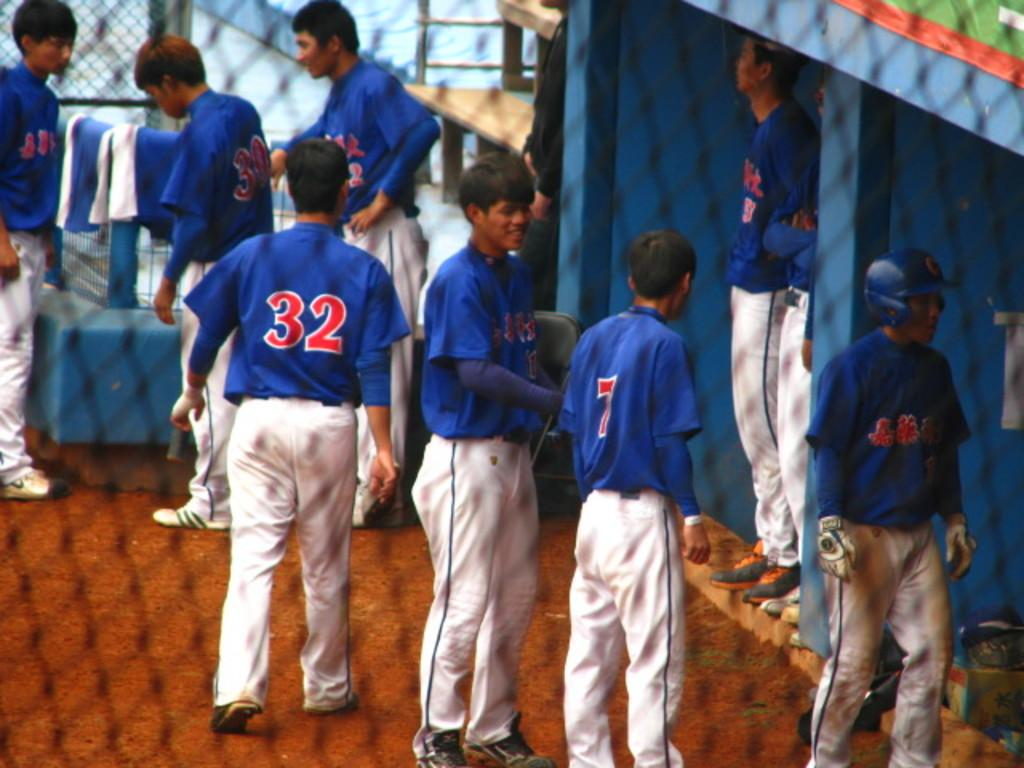<image>
Describe the image concisely. a baseball team with one of the players wearing number 32 